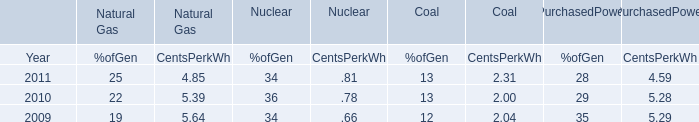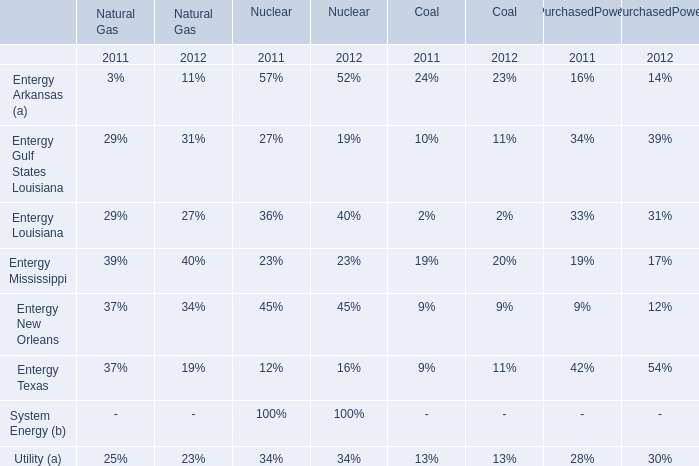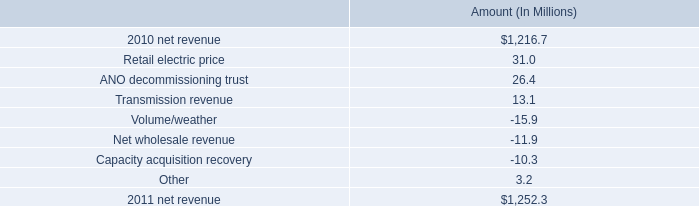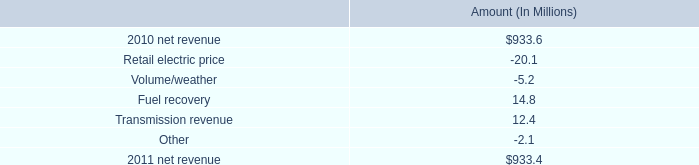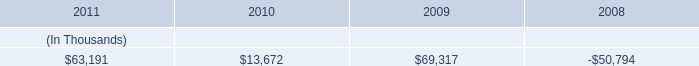what is the percent increase in net revenue from 2010 to 2011? 
Computations: ((1252.3 - 1216.7) / 1216.7)
Answer: 0.02926. 